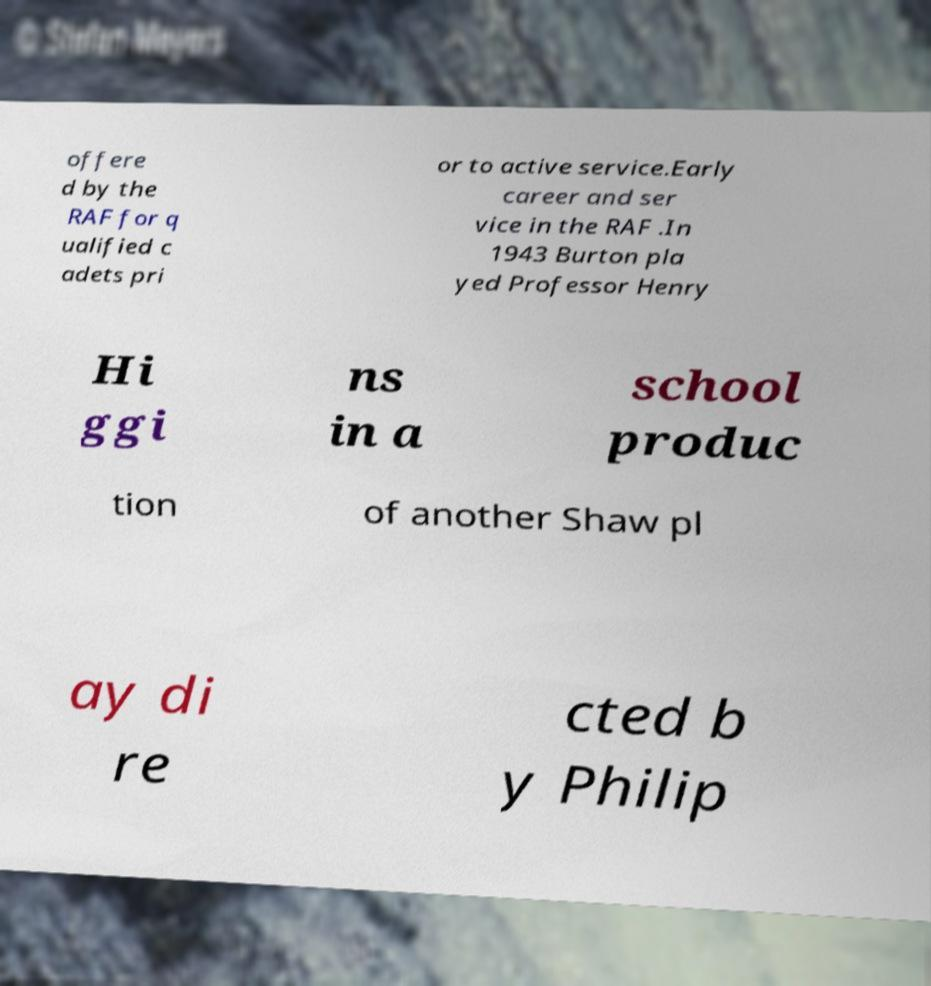Could you assist in decoding the text presented in this image and type it out clearly? offere d by the RAF for q ualified c adets pri or to active service.Early career and ser vice in the RAF .In 1943 Burton pla yed Professor Henry Hi ggi ns in a school produc tion of another Shaw pl ay di re cted b y Philip 